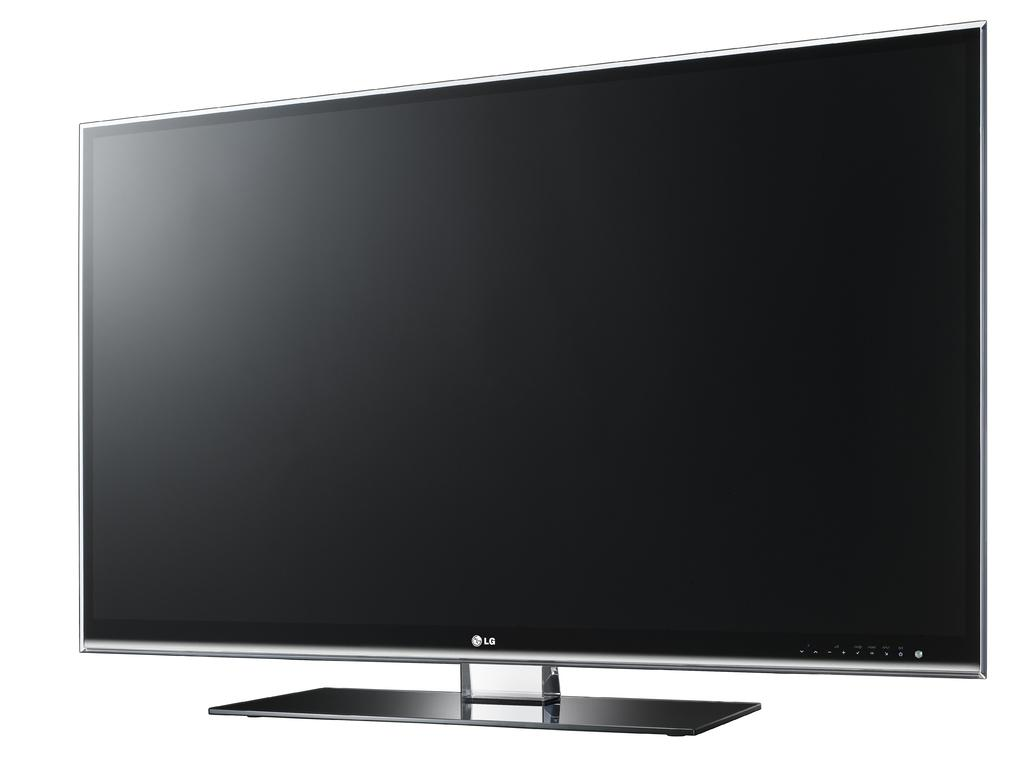What is the main object in the center of the image? There is a television in the center of the image. Can you describe the position of the television in the image? The television is in the center of the image. What type of crime is being committed by the hen in the image? There is no hen present in the image, and therefore no crime can be committed by a hen. 